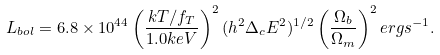Convert formula to latex. <formula><loc_0><loc_0><loc_500><loc_500>L _ { b o l } = 6 . 8 \times 1 0 ^ { 4 4 } \left ( { \frac { k T / f _ { T } } { 1 . 0 k e V } } \right ) ^ { 2 } ( h ^ { 2 } \Delta _ { c } E ^ { 2 } ) ^ { 1 / 2 } \left ( { \frac { \Omega _ { b } } { \Omega _ { m } } } \right ) ^ { 2 } e r g s ^ { - 1 } .</formula> 